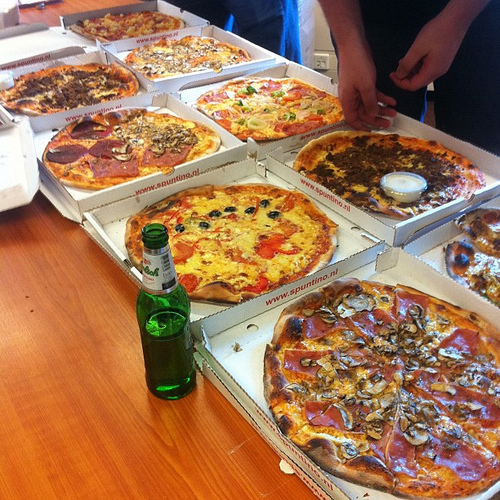In which part of the picture is the pepper, the bottom or the top? The pepper is in the top part of the picture. 